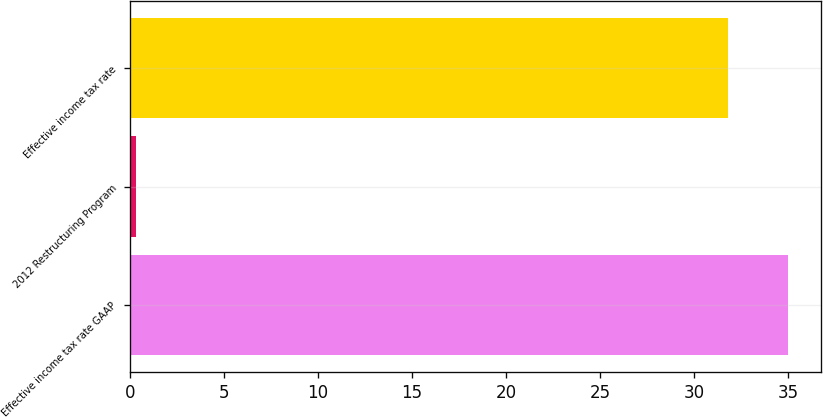Convert chart to OTSL. <chart><loc_0><loc_0><loc_500><loc_500><bar_chart><fcel>Effective income tax rate GAAP<fcel>2012 Restructuring Program<fcel>Effective income tax rate<nl><fcel>34.98<fcel>0.3<fcel>31.8<nl></chart> 